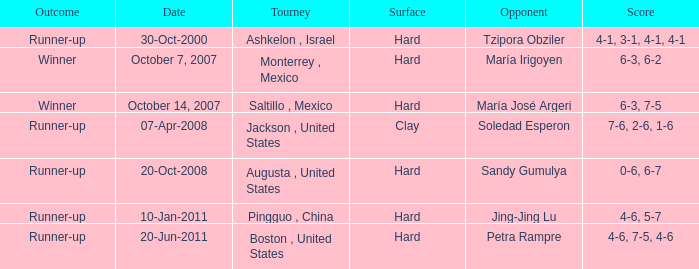What was the outcome when Jing-Jing Lu was the opponent? Runner-up. 